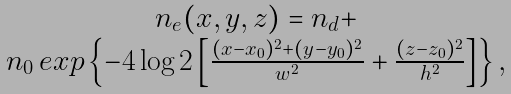Convert formula to latex. <formula><loc_0><loc_0><loc_500><loc_500>\begin{array} { c c } n _ { e } ( x , y , z ) = n _ { d } + & \\ n _ { 0 } \, e x p \left \{ - 4 \log { 2 } \left [ \frac { ( x - x _ { 0 } ) ^ { 2 } + ( y - y _ { 0 } ) ^ { 2 } } { w ^ { 2 } } + \frac { ( z - z _ { 0 } ) ^ { 2 } } { h ^ { 2 } } \right ] \right \} , & \\ \end{array}</formula> 